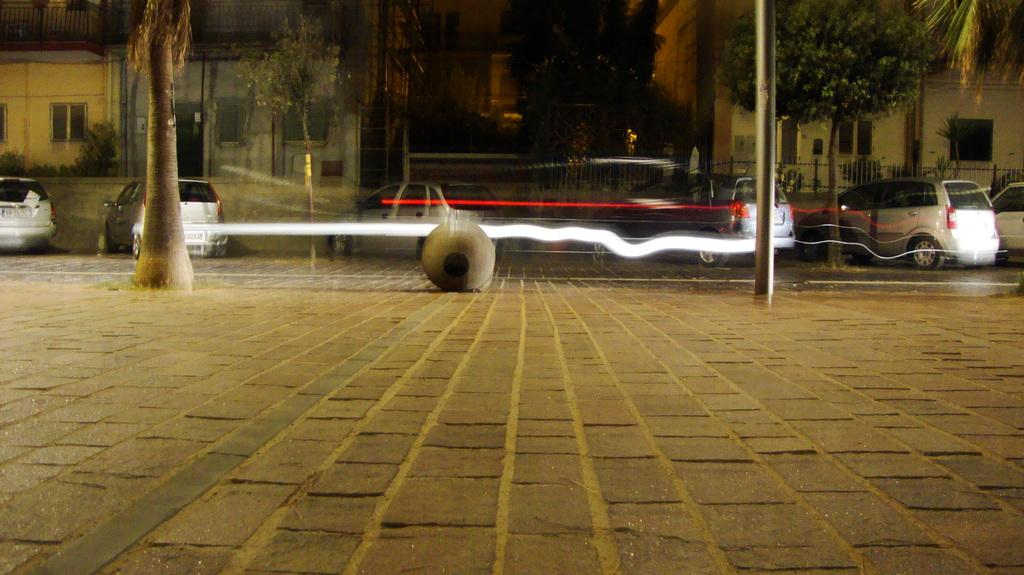What type of path is visible in the image? There is a sidewalk in the image. What type of transportation route is also present? There is a road in the image. What type of vegetation can be seen in the image? There are trees in the image. What type of structure is present in the image? There is a pole in the image. What type of vehicles are parked in the image? Cars are parked in the image. What type of structures can be seen in the background of the image? There are buildings in the background of the image. What type of barrier is visible in the background of the image? There is a fence in the background of the image. How many flowers are planted along the sidewalk in the image? There are no flowers mentioned or visible in the image. What type of cemetery is located in the background of the image? There is no cemetery present in the image; it features a sidewalk, road, trees, pole, parked cars, buildings, and a fence in the background. 